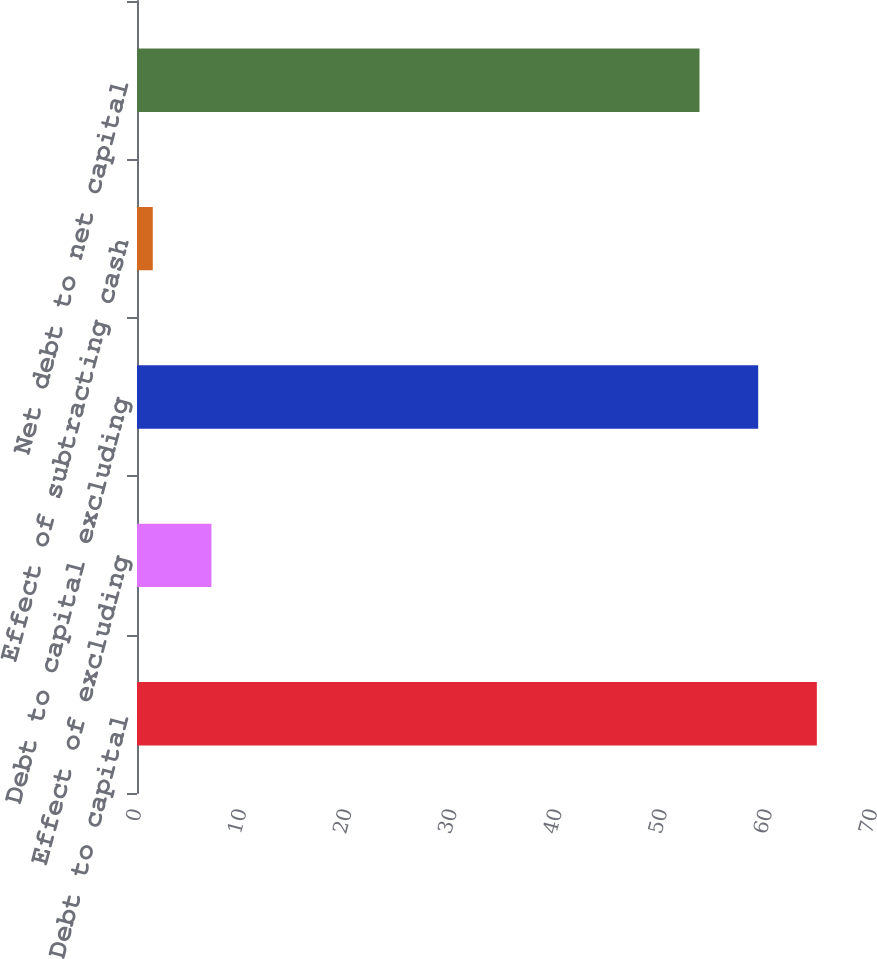<chart> <loc_0><loc_0><loc_500><loc_500><bar_chart><fcel>Debt to capital<fcel>Effect of excluding<fcel>Debt to capital excluding<fcel>Effect of subtracting cash<fcel>Net debt to net capital<nl><fcel>64.66<fcel>7.08<fcel>59.08<fcel>1.5<fcel>53.5<nl></chart> 